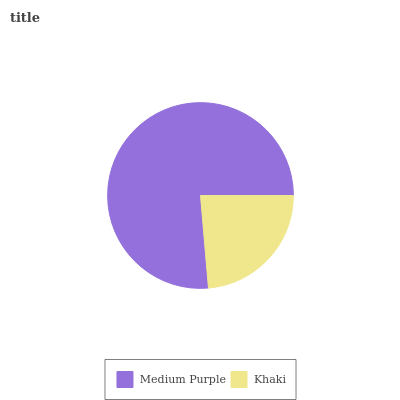Is Khaki the minimum?
Answer yes or no. Yes. Is Medium Purple the maximum?
Answer yes or no. Yes. Is Khaki the maximum?
Answer yes or no. No. Is Medium Purple greater than Khaki?
Answer yes or no. Yes. Is Khaki less than Medium Purple?
Answer yes or no. Yes. Is Khaki greater than Medium Purple?
Answer yes or no. No. Is Medium Purple less than Khaki?
Answer yes or no. No. Is Medium Purple the high median?
Answer yes or no. Yes. Is Khaki the low median?
Answer yes or no. Yes. Is Khaki the high median?
Answer yes or no. No. Is Medium Purple the low median?
Answer yes or no. No. 